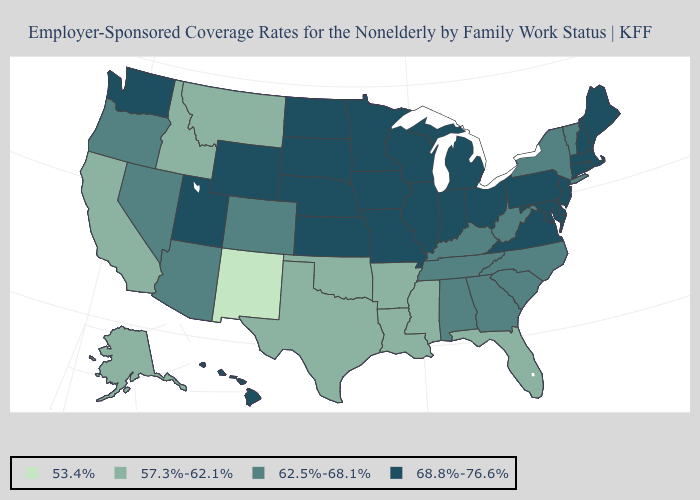What is the value of Vermont?
Be succinct. 62.5%-68.1%. What is the highest value in the USA?
Give a very brief answer. 68.8%-76.6%. Name the states that have a value in the range 57.3%-62.1%?
Quick response, please. Alaska, Arkansas, California, Florida, Idaho, Louisiana, Mississippi, Montana, Oklahoma, Texas. Which states hav the highest value in the South?
Keep it brief. Delaware, Maryland, Virginia. Name the states that have a value in the range 53.4%?
Keep it brief. New Mexico. What is the value of Indiana?
Write a very short answer. 68.8%-76.6%. Name the states that have a value in the range 68.8%-76.6%?
Answer briefly. Connecticut, Delaware, Hawaii, Illinois, Indiana, Iowa, Kansas, Maine, Maryland, Massachusetts, Michigan, Minnesota, Missouri, Nebraska, New Hampshire, New Jersey, North Dakota, Ohio, Pennsylvania, Rhode Island, South Dakota, Utah, Virginia, Washington, Wisconsin, Wyoming. Name the states that have a value in the range 62.5%-68.1%?
Quick response, please. Alabama, Arizona, Colorado, Georgia, Kentucky, Nevada, New York, North Carolina, Oregon, South Carolina, Tennessee, Vermont, West Virginia. Is the legend a continuous bar?
Give a very brief answer. No. Name the states that have a value in the range 62.5%-68.1%?
Short answer required. Alabama, Arizona, Colorado, Georgia, Kentucky, Nevada, New York, North Carolina, Oregon, South Carolina, Tennessee, Vermont, West Virginia. What is the highest value in the USA?
Concise answer only. 68.8%-76.6%. What is the highest value in the USA?
Answer briefly. 68.8%-76.6%. What is the lowest value in the South?
Give a very brief answer. 57.3%-62.1%. Which states have the highest value in the USA?
Answer briefly. Connecticut, Delaware, Hawaii, Illinois, Indiana, Iowa, Kansas, Maine, Maryland, Massachusetts, Michigan, Minnesota, Missouri, Nebraska, New Hampshire, New Jersey, North Dakota, Ohio, Pennsylvania, Rhode Island, South Dakota, Utah, Virginia, Washington, Wisconsin, Wyoming. 